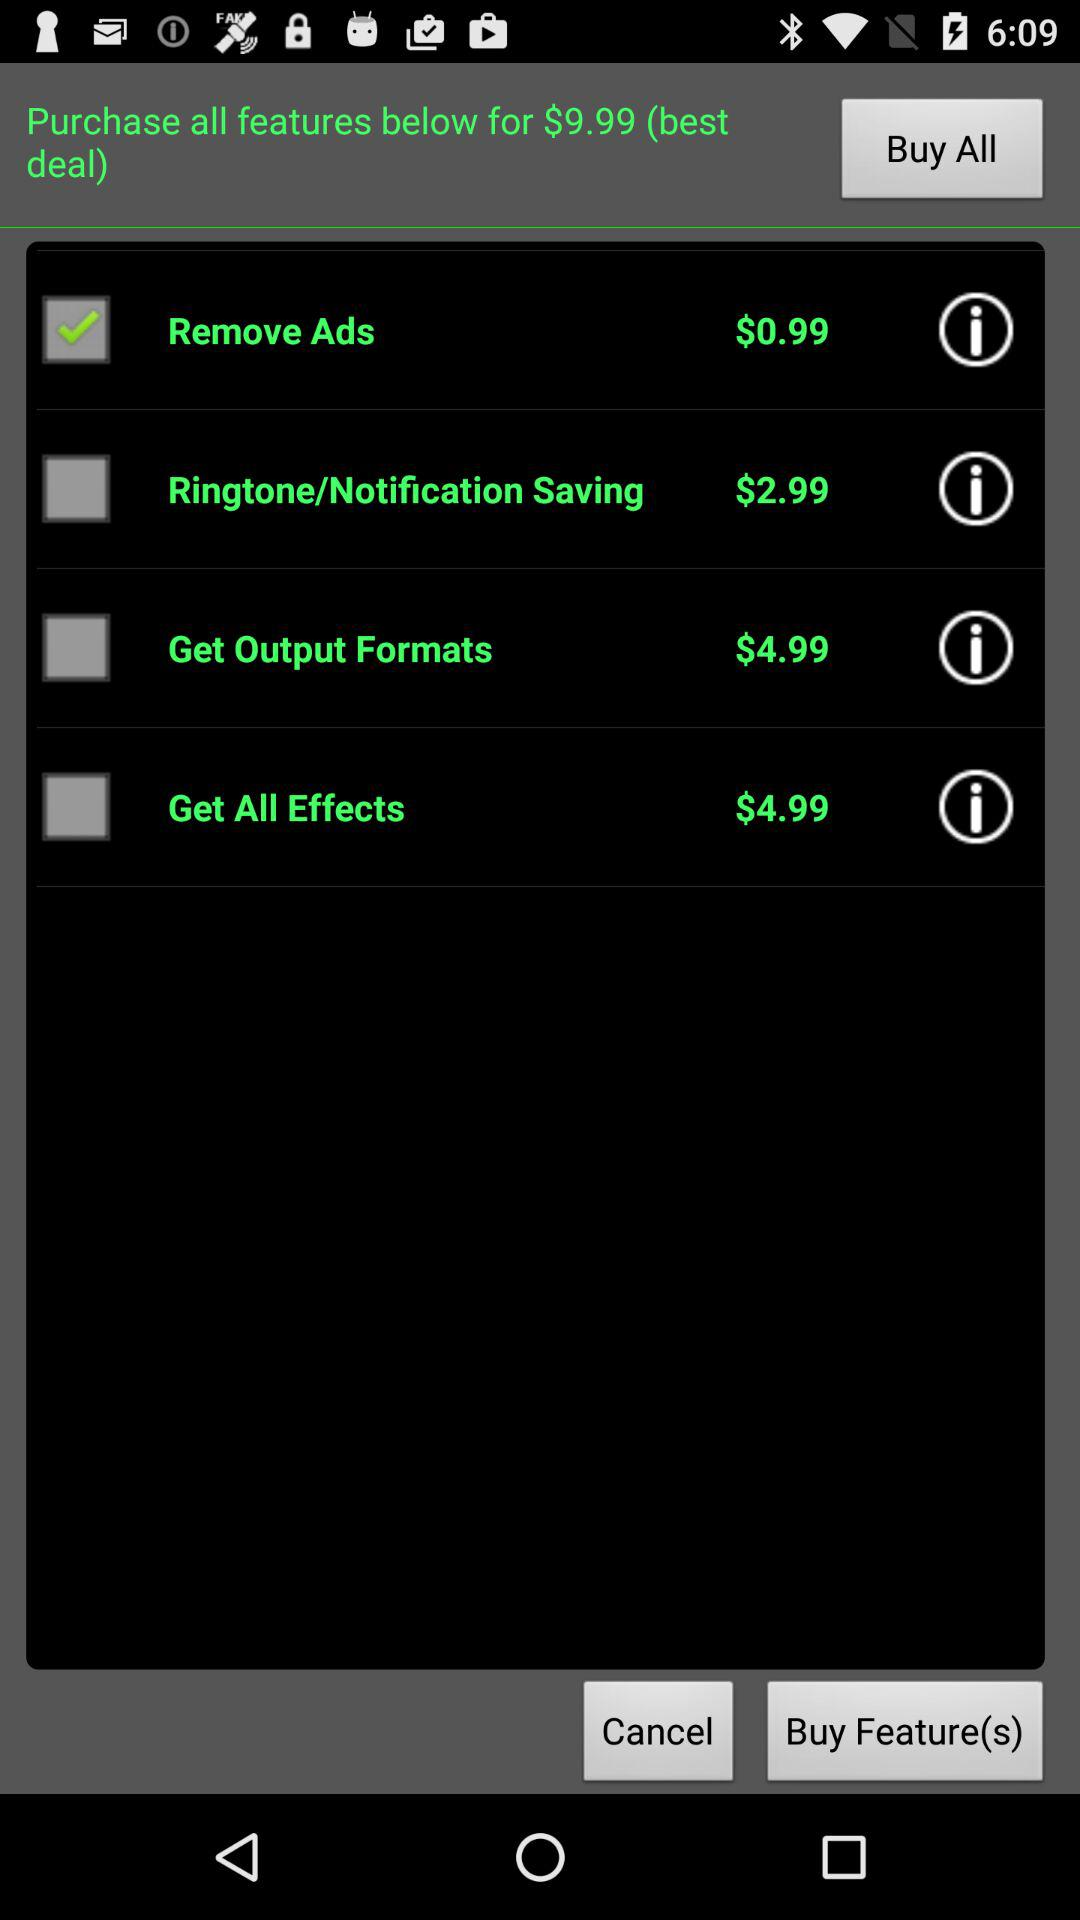How many features are there in total?
Answer the question using a single word or phrase. 4 